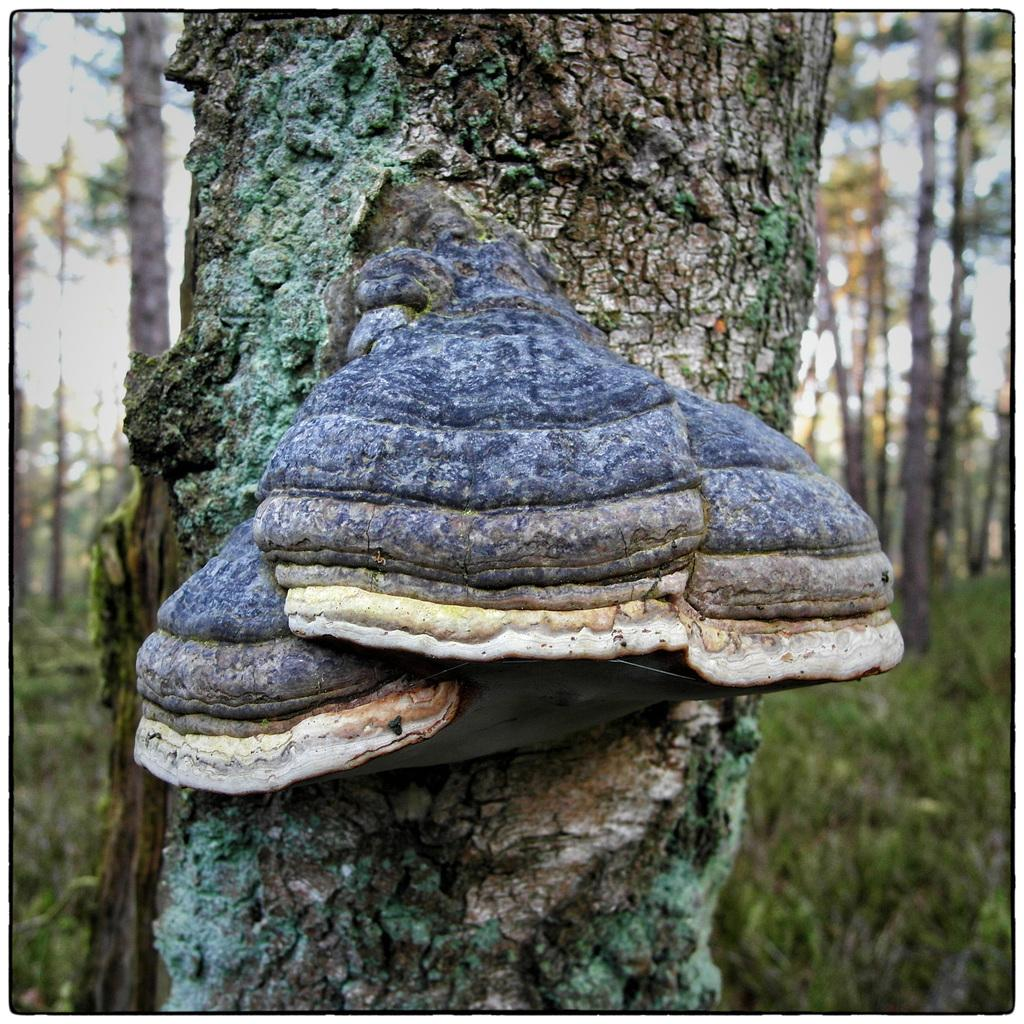What type of vegetation can be seen in the image? There are trees in the image. What are the grandfather and friends doing at the protest in the image? There is no grandfather, friends, or protest present in the image; it only features trees. 